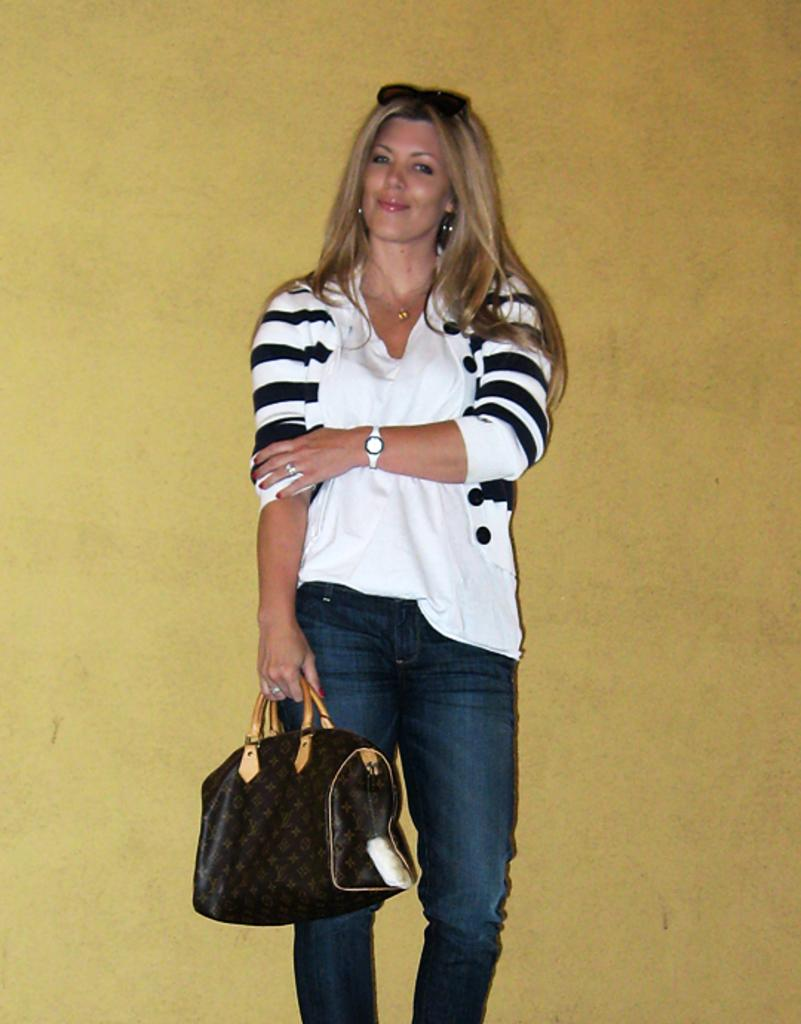What is the person in the image doing? The person is standing and smiling. What is the person holding in the image? The person is holding a bag. What accessory is the person wearing in the image? The person is wearing glasses. What can be seen in the background of the image? There is a wall in the background of the image. What type of advice can be seen written on the wall in the image? There is no advice written on the wall in the image; it is simply a wall in the background. 